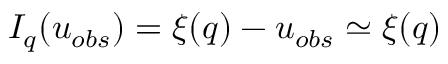Convert formula to latex. <formula><loc_0><loc_0><loc_500><loc_500>I _ { q } ( u _ { o b s } ) = \xi ( q ) - u _ { o b s } \simeq \xi ( q )</formula> 